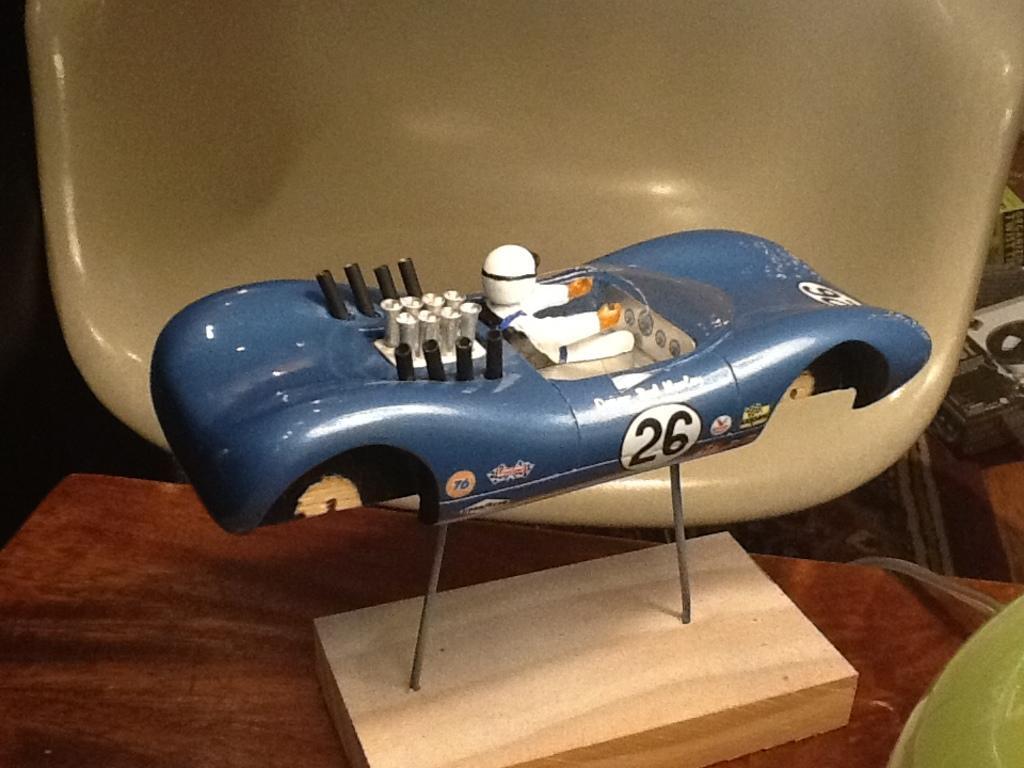In one or two sentences, can you explain what this image depicts? In this picture we can see an object on a platform and in the background we can see a wooden object and some objects. 